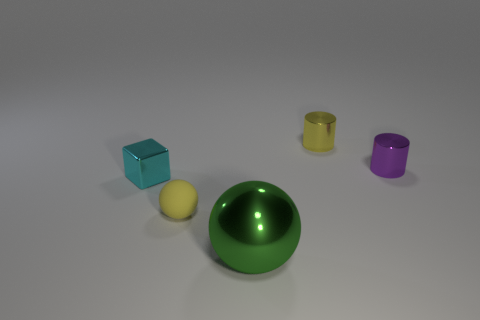There is a yellow thing behind the thing that is on the right side of the small yellow thing behind the purple shiny cylinder; what is its size?
Offer a terse response. Small. How many other things are there of the same shape as the yellow matte object?
Your answer should be very brief. 1. Is the shape of the thing on the right side of the tiny yellow shiny cylinder the same as the yellow object on the left side of the metallic sphere?
Provide a succinct answer. No. What number of cylinders are green metal things or cyan metallic objects?
Give a very brief answer. 0. What material is the sphere behind the metallic thing in front of the metal object to the left of the tiny yellow sphere made of?
Provide a short and direct response. Rubber. How many other things are there of the same size as the green ball?
Give a very brief answer. 0. The thing that is the same color as the tiny sphere is what size?
Keep it short and to the point. Small. Are there more tiny yellow metallic cylinders that are in front of the cyan metal object than gray cylinders?
Keep it short and to the point. No. Is there a metallic thing of the same color as the metallic ball?
Make the answer very short. No. There is a metallic cube that is the same size as the yellow ball; what color is it?
Make the answer very short. Cyan. 